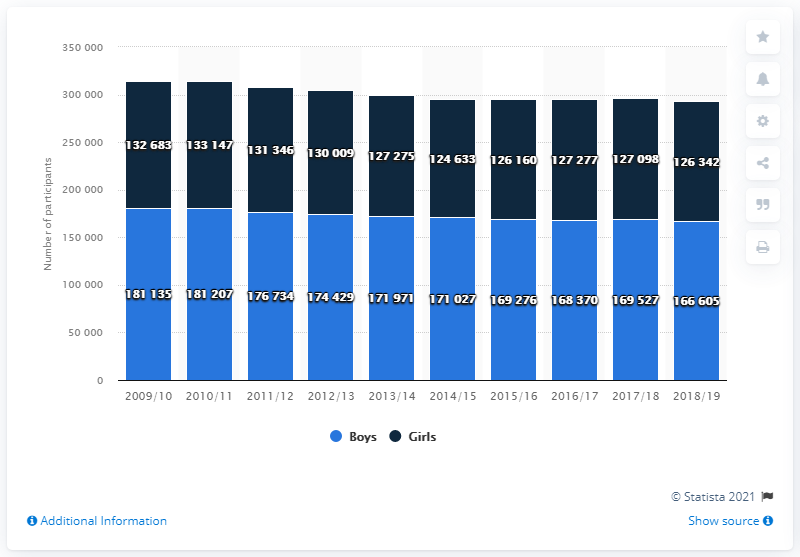What is the sum of highest value and lowest value of light blue bar?
 347740 